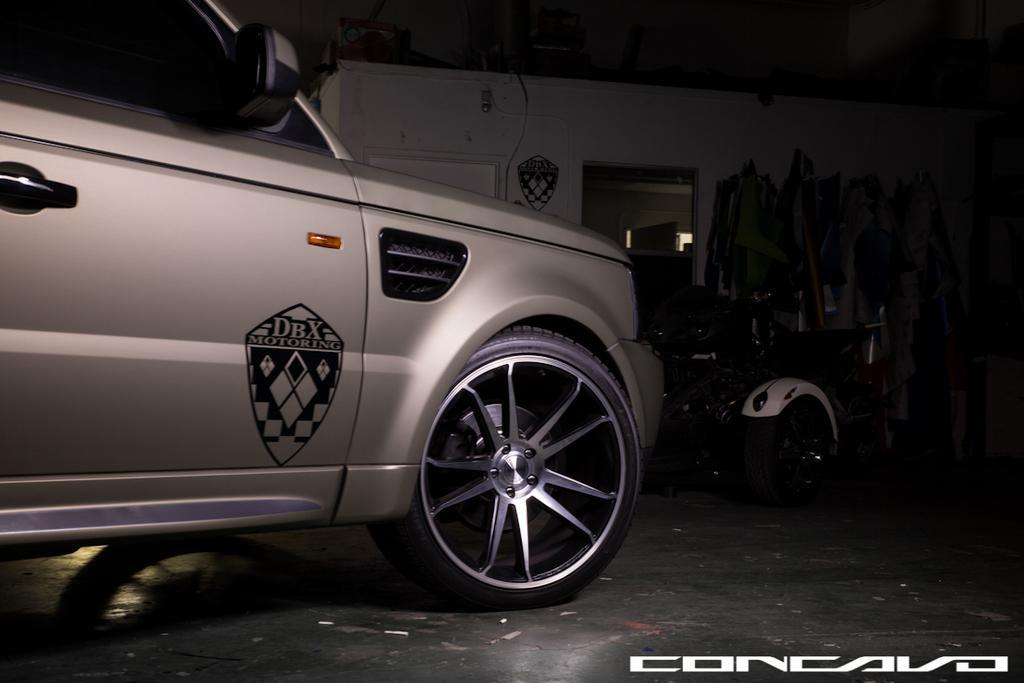Could you give a brief overview of what you see in this image? In this image I can see a room and in front of the room I can see another vehicle. 